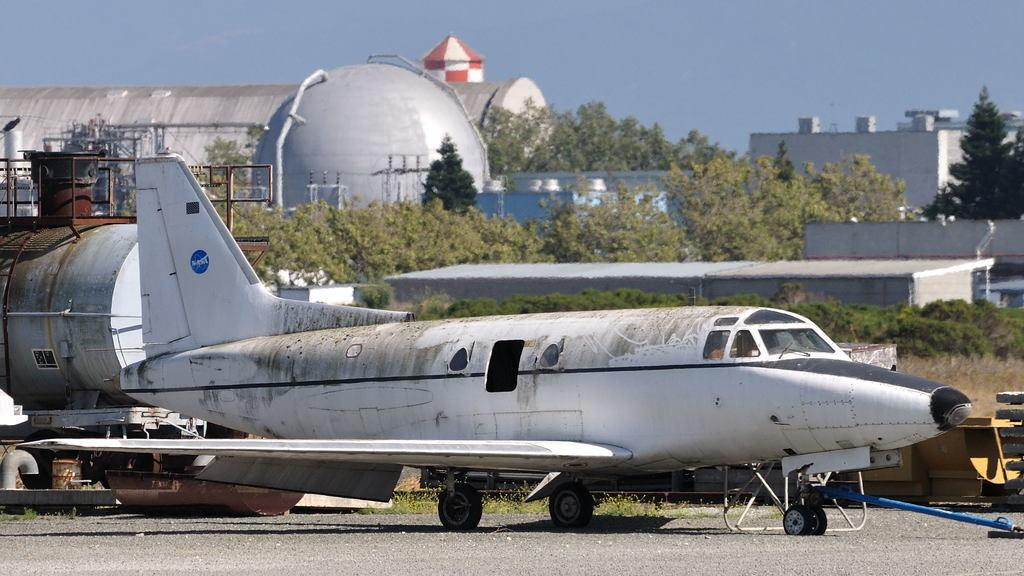What is located on the runway in the image? There is an airplane on the runway in the image. What type of vegetation is present on the ground? There is grass and plants on the ground in the image. What structures can be seen in the image? There are buildings visible in the image. What else can be seen in the image besides the airplane and vegetation? There are trees visible in the image. What is visible in the background of the image? The sky is visible in the background of the image. What type of marble is used to decorate the airplane in the image? There is no marble present in the image; it features an airplane on a runway with grass, plants, buildings, trees, and a visible sky. Can you see any twigs on the ground in the image? There is no mention of twigs in the image; it features grass, plants, buildings, trees, and a visible sky. 